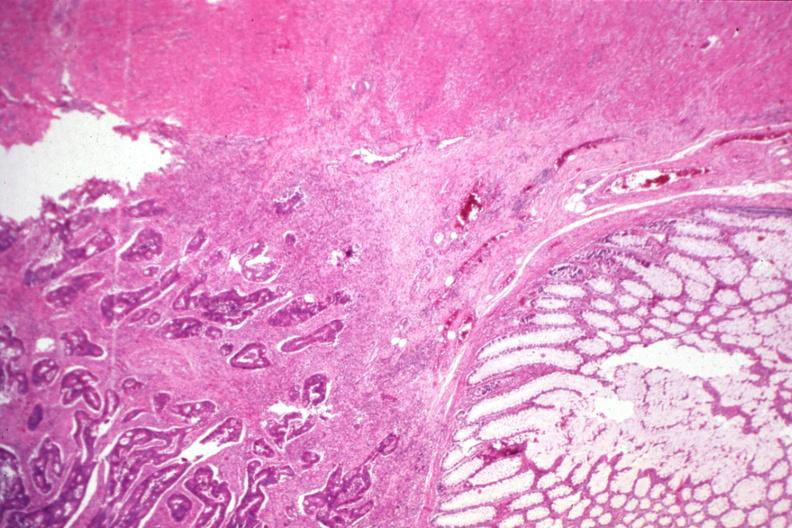s colon present?
Answer the question using a single word or phrase. Yes 